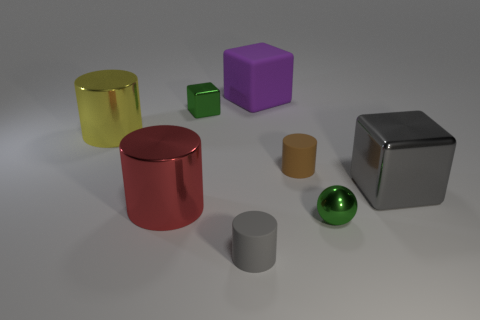What is the shape of the tiny metal thing that is the same color as the small metallic ball?
Provide a short and direct response. Cube. What is the thing that is both right of the brown cylinder and left of the gray block made of?
Your response must be concise. Metal. There is a large metallic thing behind the brown rubber object; what is its shape?
Provide a succinct answer. Cylinder. What is the shape of the big metal thing on the right side of the brown cylinder that is on the right side of the red shiny thing?
Give a very brief answer. Cube. Are there any purple things of the same shape as the gray shiny thing?
Ensure brevity in your answer.  Yes. There is a gray shiny thing that is the same size as the red shiny object; what shape is it?
Your answer should be very brief. Cube. Is there a big block that is in front of the big cube in front of the metal thing behind the yellow object?
Ensure brevity in your answer.  No. Are there any brown cylinders of the same size as the green shiny sphere?
Provide a succinct answer. Yes. How big is the matte cylinder that is in front of the red object?
Provide a short and direct response. Small. The large block right of the small metallic thing in front of the small thing on the left side of the tiny gray cylinder is what color?
Ensure brevity in your answer.  Gray. 